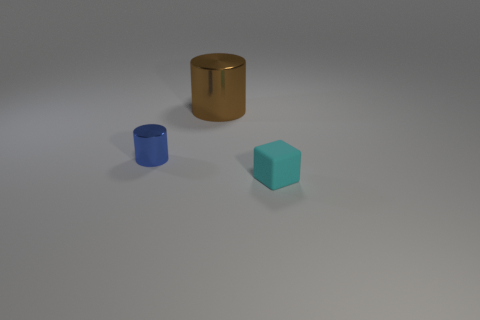Add 3 big brown metal objects. How many objects exist? 6 Subtract all cylinders. How many objects are left? 1 Add 3 cyan rubber objects. How many cyan rubber objects are left? 4 Add 3 green matte things. How many green matte things exist? 3 Subtract 0 red balls. How many objects are left? 3 Subtract all brown cylinders. Subtract all big brown cylinders. How many objects are left? 1 